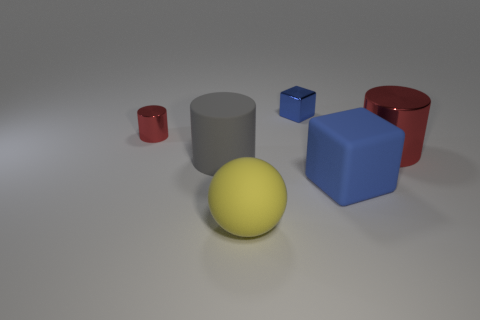How many other objects are the same color as the big cube?
Your answer should be very brief. 1. There is a cube that is behind the big blue object; does it have the same size as the red object right of the matte ball?
Keep it short and to the point. No. There is a metallic cylinder to the left of the tiny blue shiny cube; what is its color?
Give a very brief answer. Red. Is the number of big yellow matte objects that are behind the large block less than the number of small red matte cylinders?
Offer a terse response. No. Is the material of the gray cylinder the same as the large yellow ball?
Your answer should be compact. Yes. What is the size of the other red shiny object that is the same shape as the big shiny object?
Your response must be concise. Small. What number of objects are red metal objects left of the gray matte thing or red metal cylinders that are to the left of the big block?
Keep it short and to the point. 1. Are there fewer shiny spheres than tiny shiny objects?
Keep it short and to the point. Yes. There is a blue matte block; is it the same size as the cylinder that is to the right of the large rubber sphere?
Your answer should be very brief. Yes. What number of matte objects are either blue cylinders or tiny red things?
Your answer should be very brief. 0. 